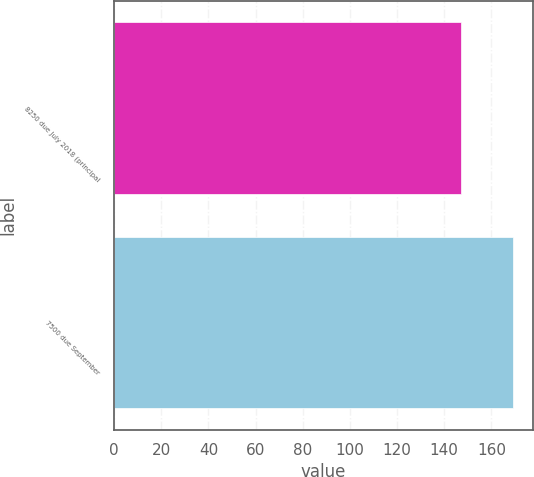Convert chart. <chart><loc_0><loc_0><loc_500><loc_500><bar_chart><fcel>8250 due July 2018 (principal<fcel>7500 due September<nl><fcel>147<fcel>169<nl></chart> 